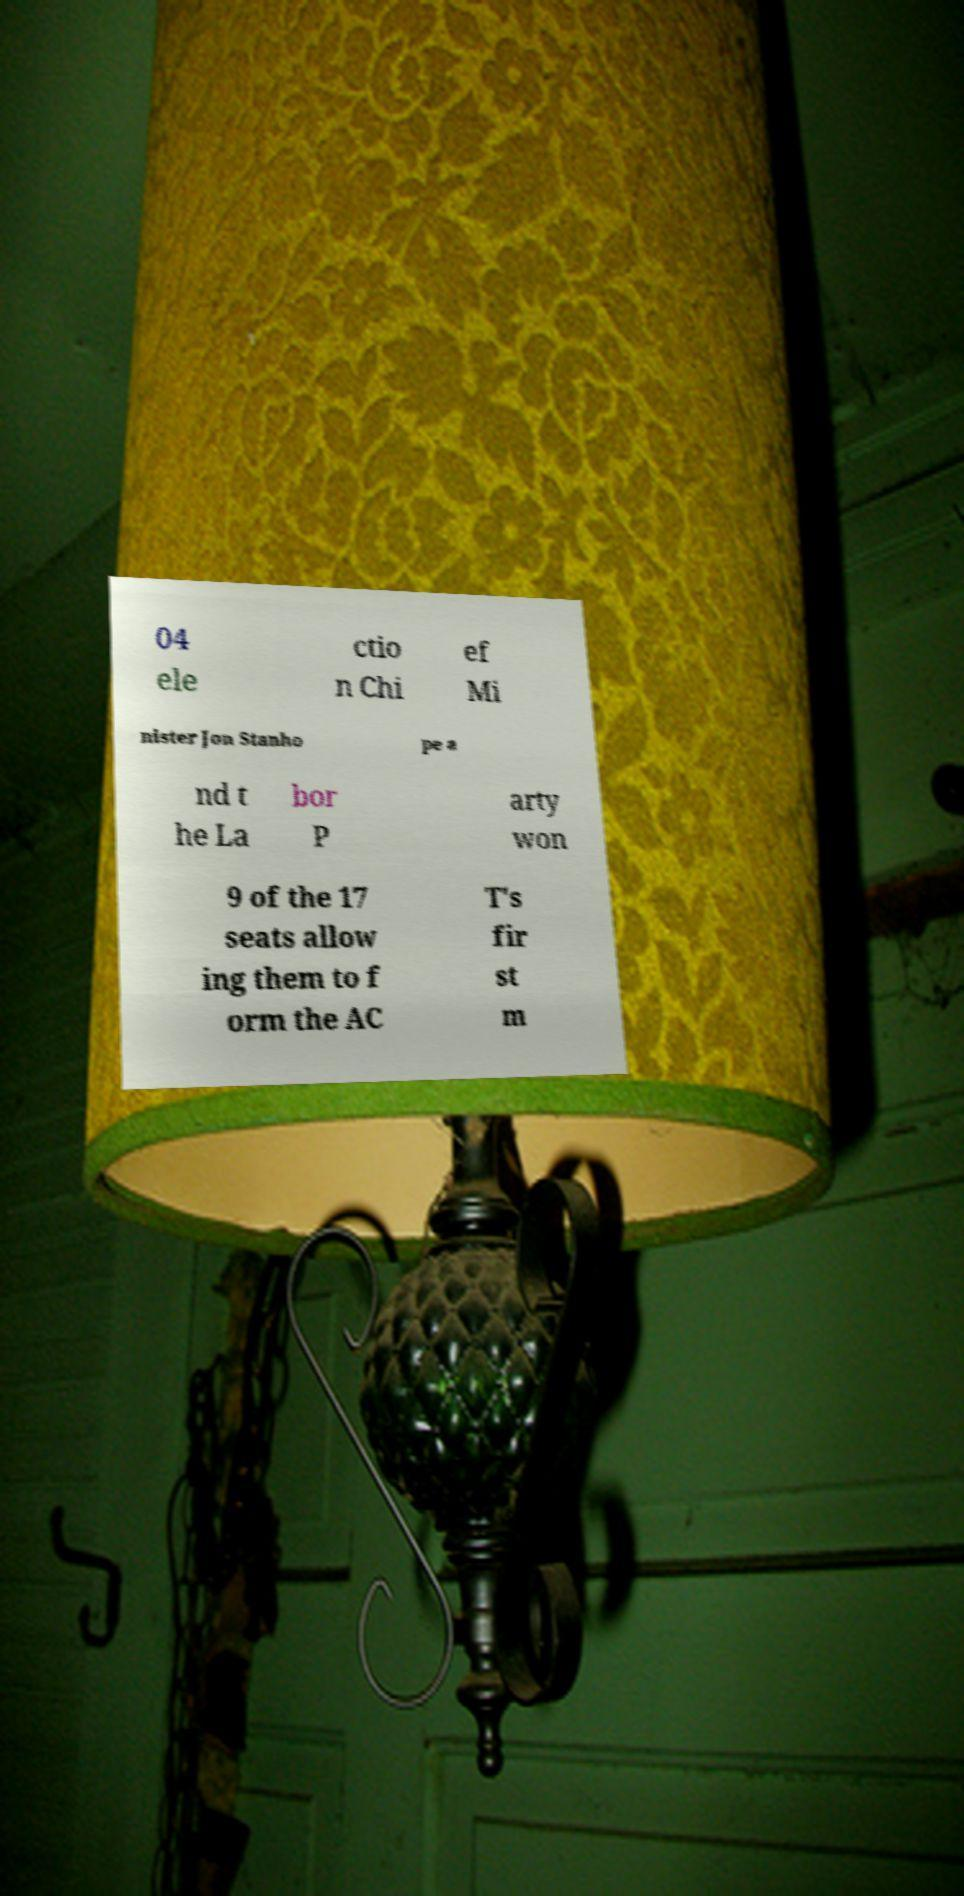For documentation purposes, I need the text within this image transcribed. Could you provide that? 04 ele ctio n Chi ef Mi nister Jon Stanho pe a nd t he La bor P arty won 9 of the 17 seats allow ing them to f orm the AC T's fir st m 